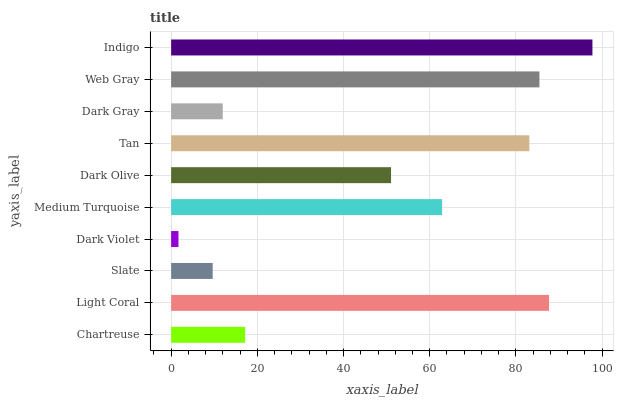Is Dark Violet the minimum?
Answer yes or no. Yes. Is Indigo the maximum?
Answer yes or no. Yes. Is Light Coral the minimum?
Answer yes or no. No. Is Light Coral the maximum?
Answer yes or no. No. Is Light Coral greater than Chartreuse?
Answer yes or no. Yes. Is Chartreuse less than Light Coral?
Answer yes or no. Yes. Is Chartreuse greater than Light Coral?
Answer yes or no. No. Is Light Coral less than Chartreuse?
Answer yes or no. No. Is Medium Turquoise the high median?
Answer yes or no. Yes. Is Dark Olive the low median?
Answer yes or no. Yes. Is Tan the high median?
Answer yes or no. No. Is Web Gray the low median?
Answer yes or no. No. 